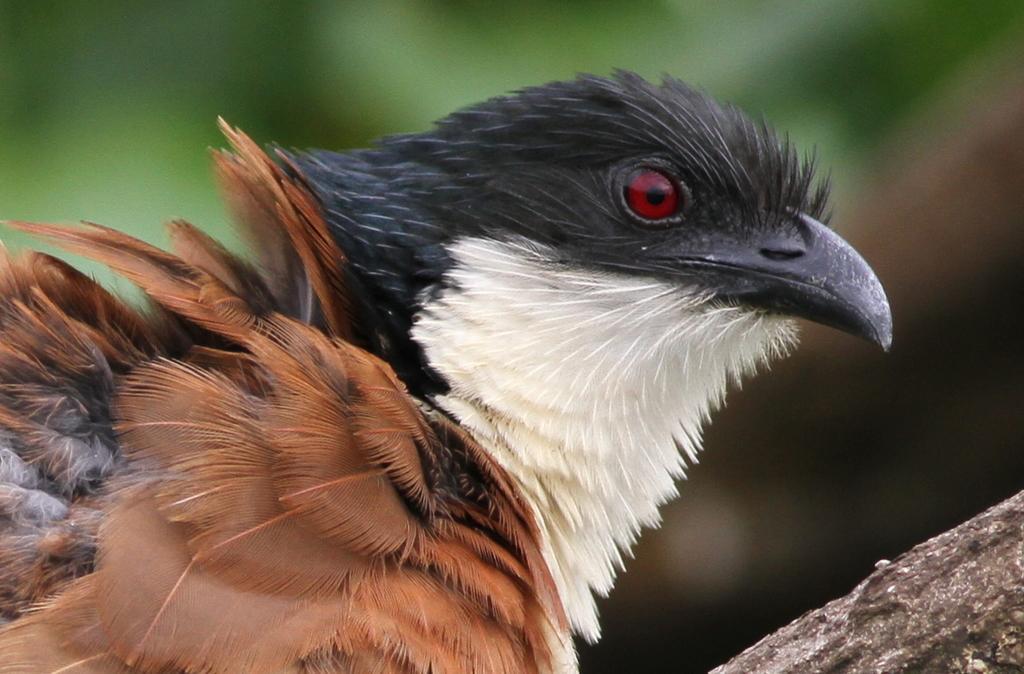Can you describe this image briefly? In this image I can see the bird and the bird is in black, white and brown color and I can see the green color background. 